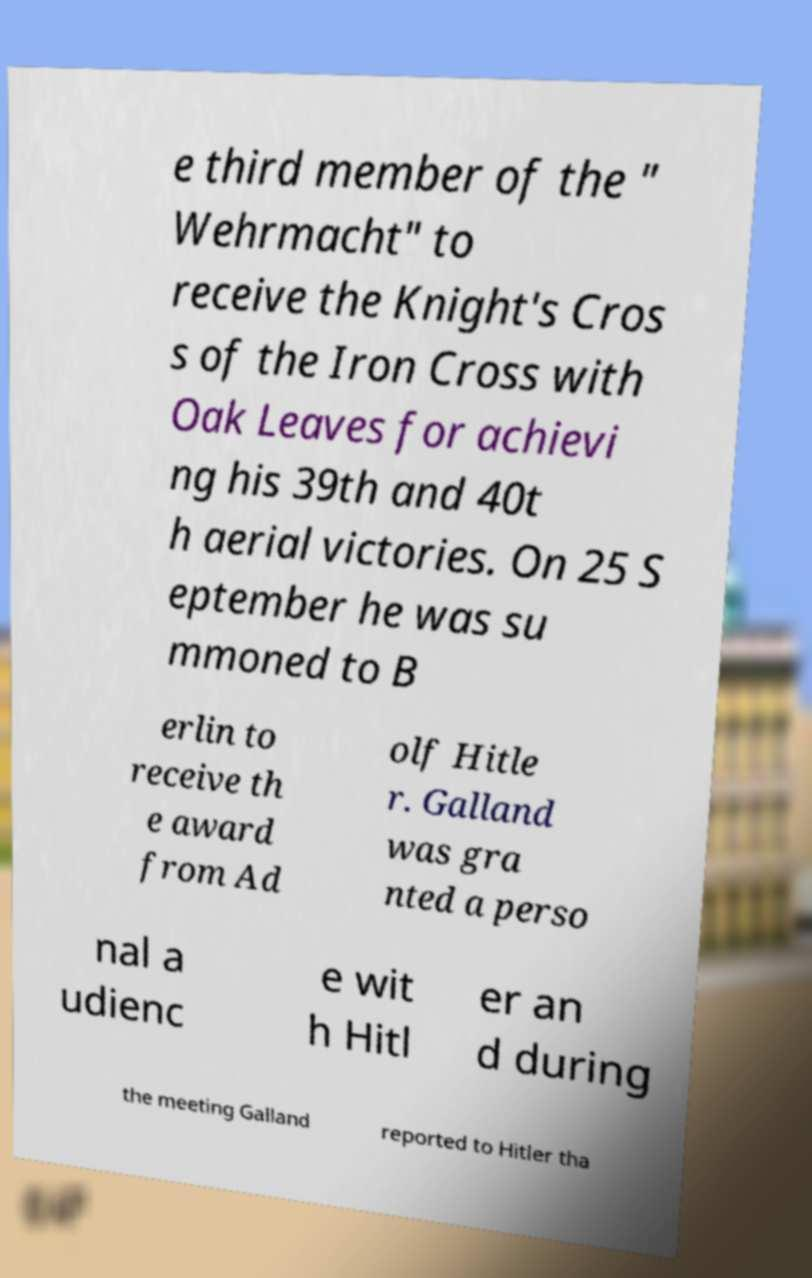Please identify and transcribe the text found in this image. e third member of the " Wehrmacht" to receive the Knight's Cros s of the Iron Cross with Oak Leaves for achievi ng his 39th and 40t h aerial victories. On 25 S eptember he was su mmoned to B erlin to receive th e award from Ad olf Hitle r. Galland was gra nted a perso nal a udienc e wit h Hitl er an d during the meeting Galland reported to Hitler tha 